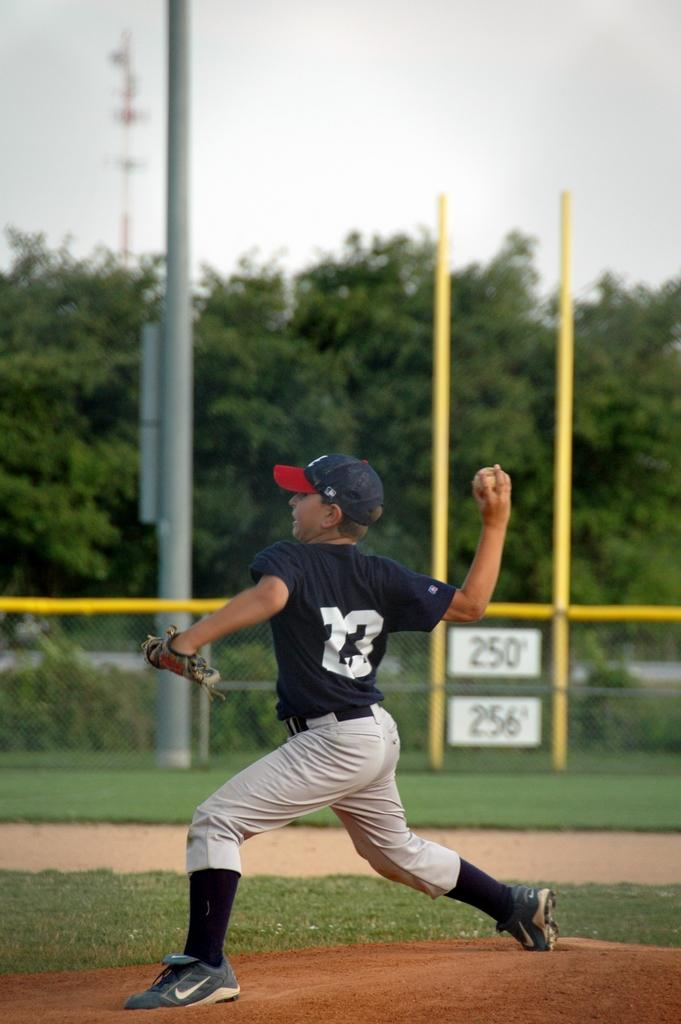<image>
Present a compact description of the photo's key features. Number 23 is pitches the ball in a baseball game. 